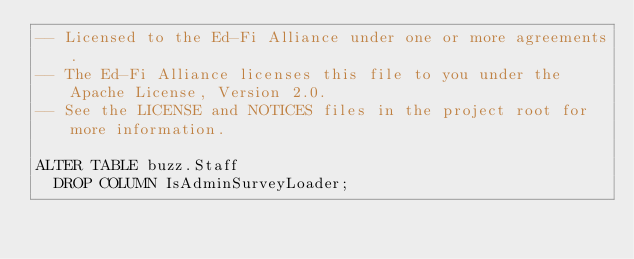<code> <loc_0><loc_0><loc_500><loc_500><_SQL_>-- Licensed to the Ed-Fi Alliance under one or more agreements.
-- The Ed-Fi Alliance licenses this file to you under the Apache License, Version 2.0.
-- See the LICENSE and NOTICES files in the project root for more information.

ALTER TABLE buzz.Staff
  DROP COLUMN IsAdminSurveyLoader;
</code> 